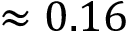<formula> <loc_0><loc_0><loc_500><loc_500>\approx 0 . 1 6</formula> 